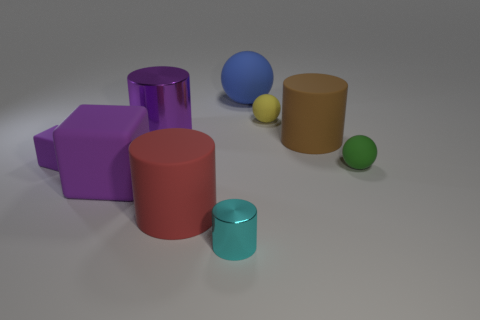Subtract all small spheres. How many spheres are left? 1 Subtract 2 blocks. How many blocks are left? 0 Subtract all green balls. How many balls are left? 2 Subtract all cyan cylinders. Subtract all green blocks. How many cylinders are left? 3 Subtract all yellow cubes. How many yellow spheres are left? 1 Subtract all green rubber things. Subtract all small rubber spheres. How many objects are left? 6 Add 5 purple metallic things. How many purple metallic things are left? 6 Add 2 big red matte things. How many big red matte things exist? 3 Subtract 0 gray balls. How many objects are left? 9 Subtract all cubes. How many objects are left? 7 